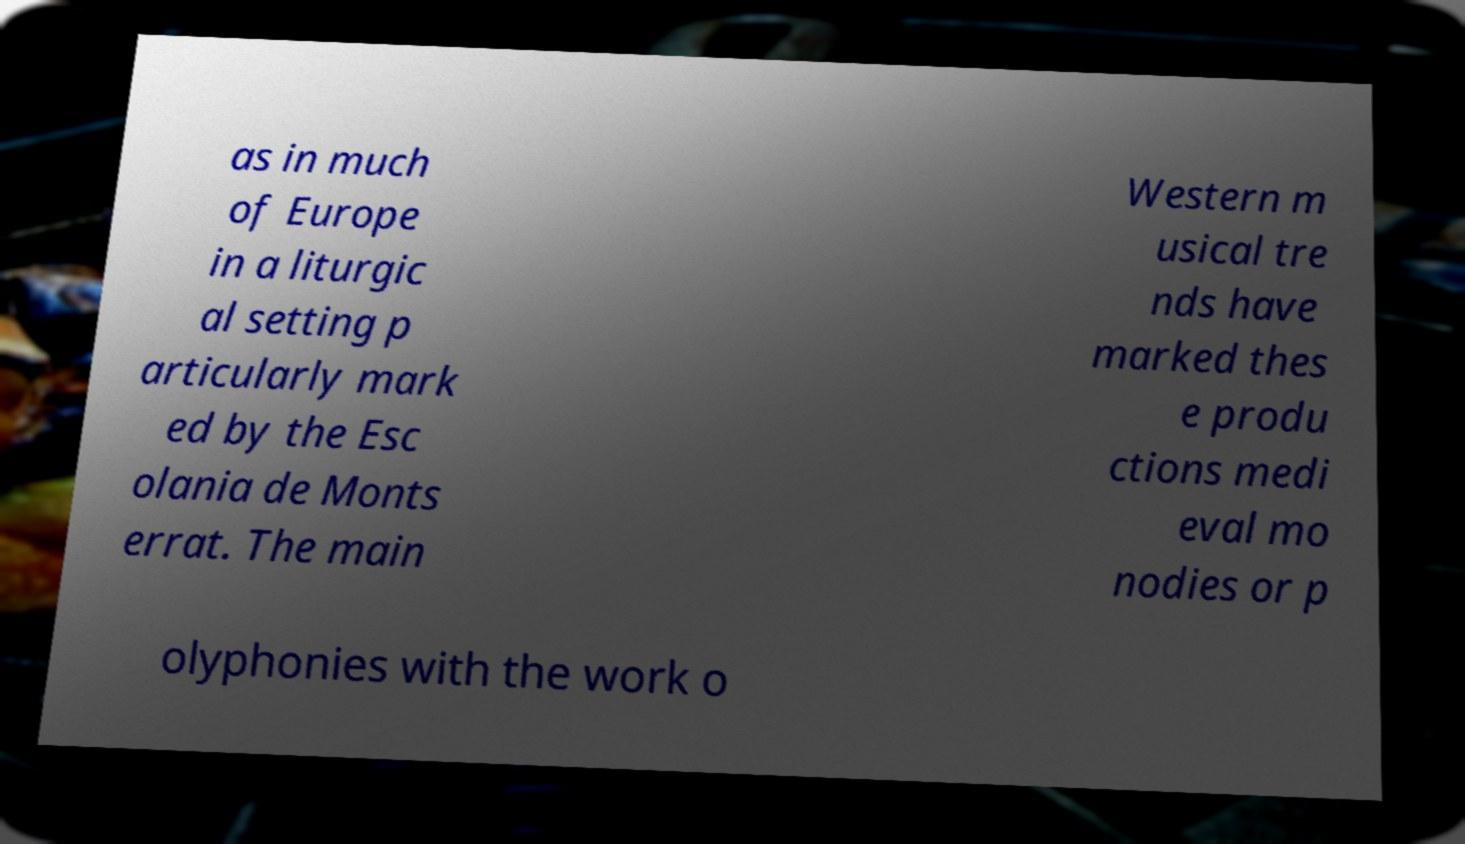For documentation purposes, I need the text within this image transcribed. Could you provide that? as in much of Europe in a liturgic al setting p articularly mark ed by the Esc olania de Monts errat. The main Western m usical tre nds have marked thes e produ ctions medi eval mo nodies or p olyphonies with the work o 